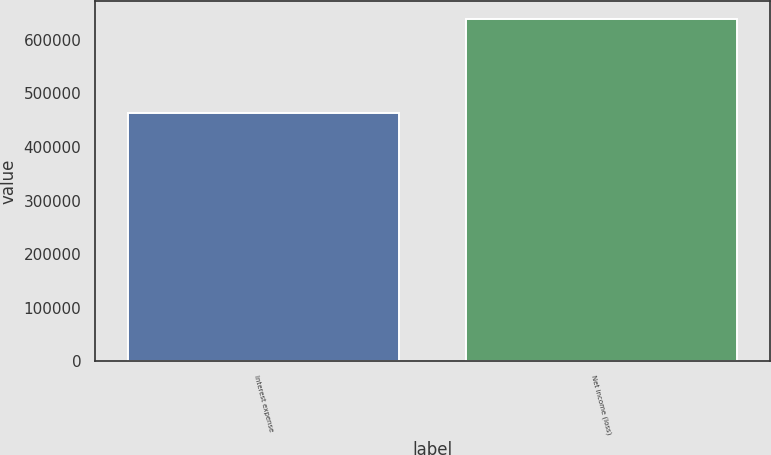<chart> <loc_0><loc_0><loc_500><loc_500><bar_chart><fcel>Interest expense<fcel>Net income (loss)<nl><fcel>464403<fcel>639926<nl></chart> 